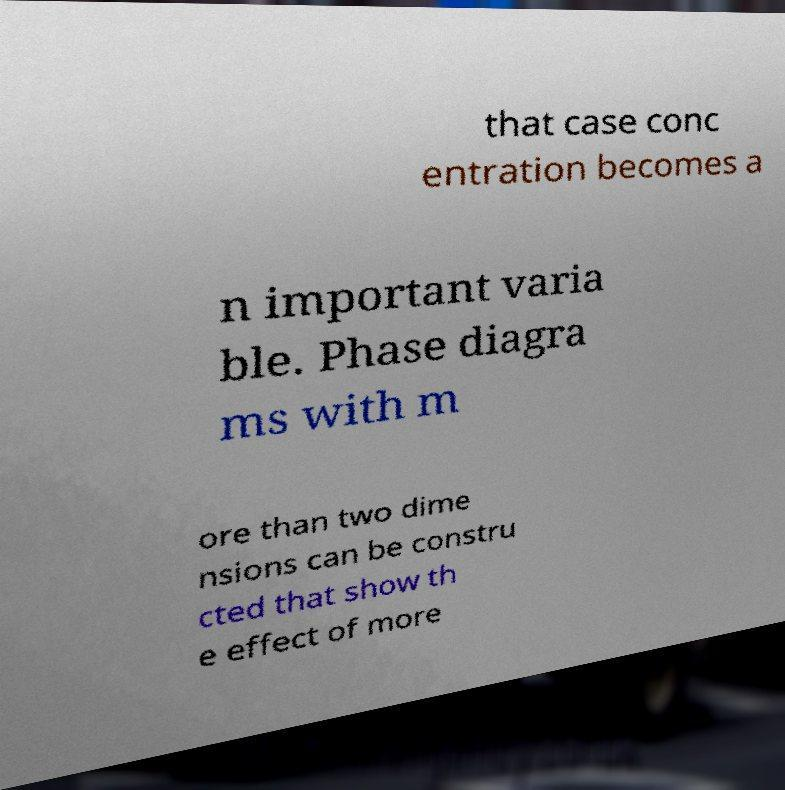Can you accurately transcribe the text from the provided image for me? that case conc entration becomes a n important varia ble. Phase diagra ms with m ore than two dime nsions can be constru cted that show th e effect of more 